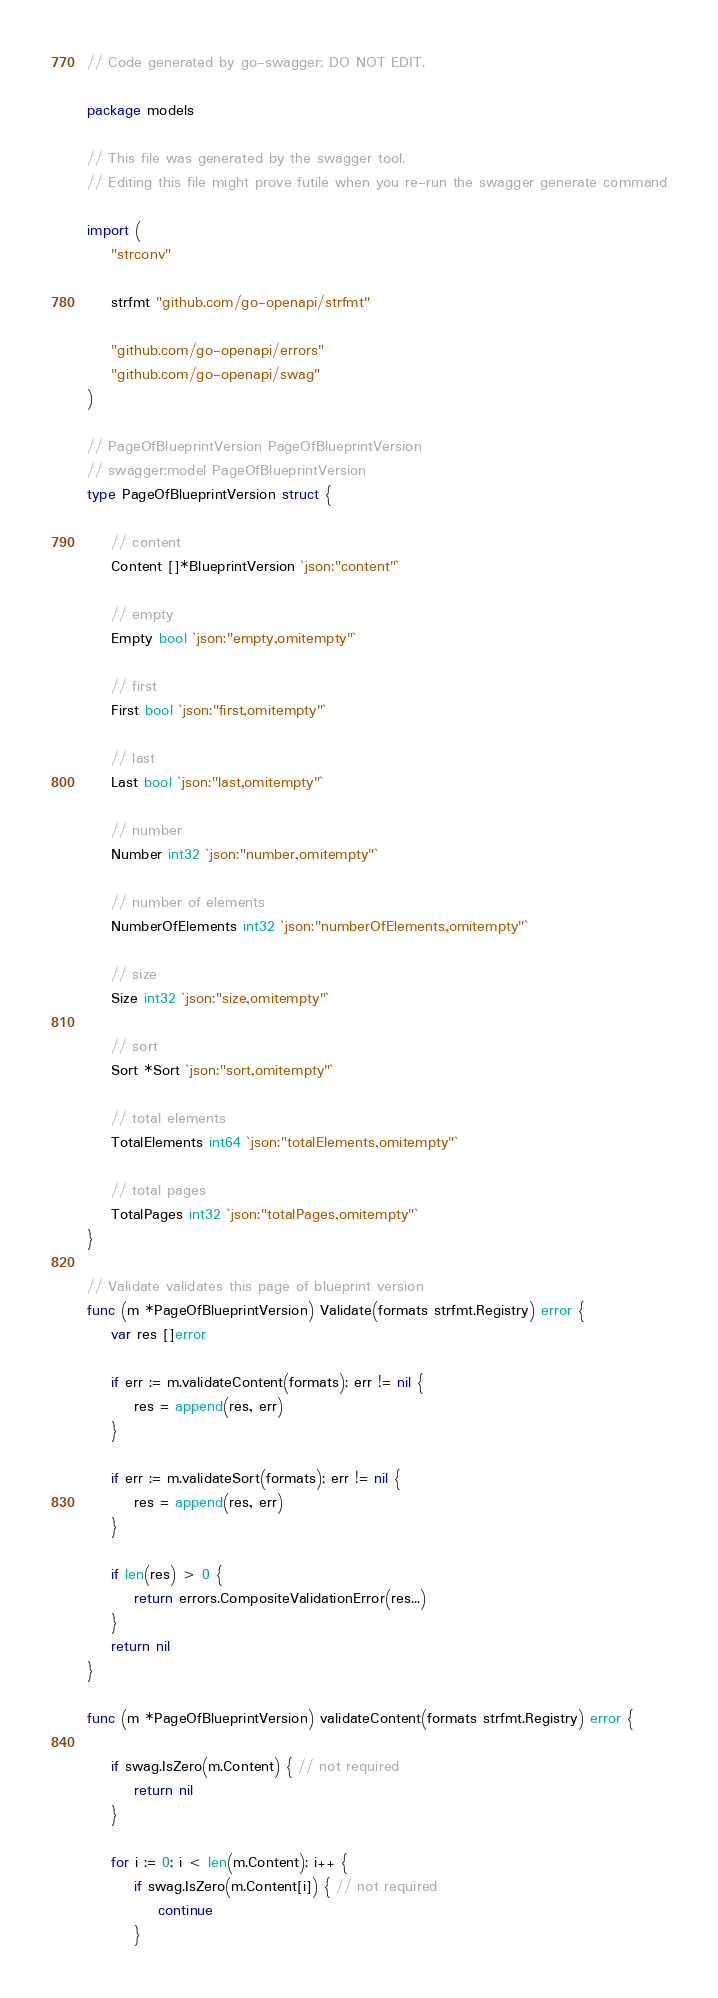<code> <loc_0><loc_0><loc_500><loc_500><_Go_>// Code generated by go-swagger; DO NOT EDIT.

package models

// This file was generated by the swagger tool.
// Editing this file might prove futile when you re-run the swagger generate command

import (
	"strconv"

	strfmt "github.com/go-openapi/strfmt"

	"github.com/go-openapi/errors"
	"github.com/go-openapi/swag"
)

// PageOfBlueprintVersion PageOfBlueprintVersion
// swagger:model PageOfBlueprintVersion
type PageOfBlueprintVersion struct {

	// content
	Content []*BlueprintVersion `json:"content"`

	// empty
	Empty bool `json:"empty,omitempty"`

	// first
	First bool `json:"first,omitempty"`

	// last
	Last bool `json:"last,omitempty"`

	// number
	Number int32 `json:"number,omitempty"`

	// number of elements
	NumberOfElements int32 `json:"numberOfElements,omitempty"`

	// size
	Size int32 `json:"size,omitempty"`

	// sort
	Sort *Sort `json:"sort,omitempty"`

	// total elements
	TotalElements int64 `json:"totalElements,omitempty"`

	// total pages
	TotalPages int32 `json:"totalPages,omitempty"`
}

// Validate validates this page of blueprint version
func (m *PageOfBlueprintVersion) Validate(formats strfmt.Registry) error {
	var res []error

	if err := m.validateContent(formats); err != nil {
		res = append(res, err)
	}

	if err := m.validateSort(formats); err != nil {
		res = append(res, err)
	}

	if len(res) > 0 {
		return errors.CompositeValidationError(res...)
	}
	return nil
}

func (m *PageOfBlueprintVersion) validateContent(formats strfmt.Registry) error {

	if swag.IsZero(m.Content) { // not required
		return nil
	}

	for i := 0; i < len(m.Content); i++ {
		if swag.IsZero(m.Content[i]) { // not required
			continue
		}
</code> 